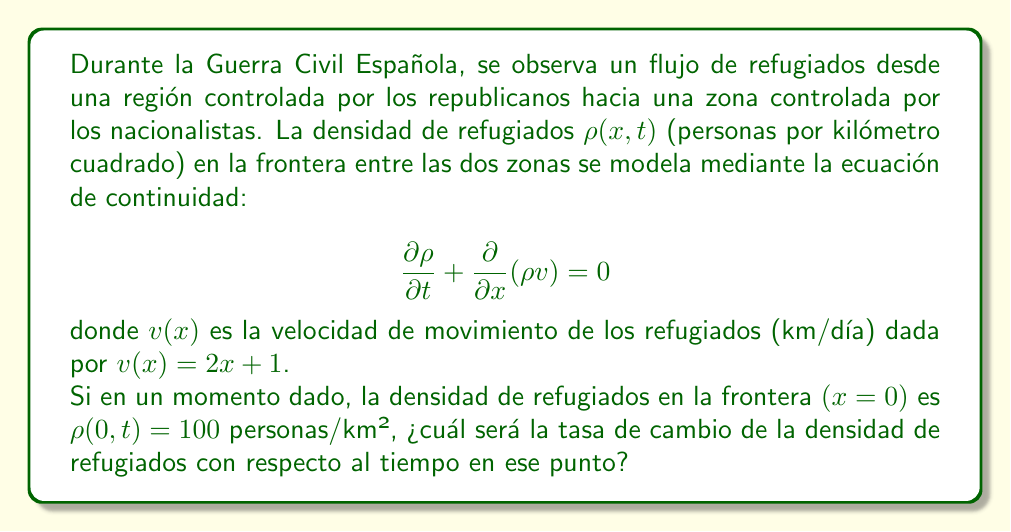Give your solution to this math problem. Para resolver este problema, seguiremos estos pasos:

1) La ecuación de continuidad dada es:

   $$\frac{\partial \rho}{\partial t} + \frac{\partial}{\partial x}(\rho v) = 0$$

2) Expandimos el segundo término usando la regla del producto:

   $$\frac{\partial \rho}{\partial t} + v\frac{\partial \rho}{\partial x} + \rho\frac{\partial v}{\partial x} = 0$$

3) Nos dan que $v(x) = 2x + 1$, por lo que $\frac{\partial v}{\partial x} = 2$

4) Sustituyendo esto en la ecuación:

   $$\frac{\partial \rho}{\partial t} + (2x + 1)\frac{\partial \rho}{\partial x} + 2\rho = 0$$

5) Nos piden evaluar en $x = 0$, donde $\rho = 100$. Sustituyendo estos valores:

   $$\frac{\partial \rho}{\partial t} + 1\frac{\partial \rho}{\partial x} + 2(100) = 0$$

6) Despejando $\frac{\partial \rho}{\partial t}$:

   $$\frac{\partial \rho}{\partial t} = -\frac{\partial \rho}{\partial x} - 200$$

Esta ecuación nos da la tasa de cambio de la densidad de refugiados con respecto al tiempo en términos de la tasa de cambio espacial de la densidad y un término constante.

7) Aunque no conocemos el valor exacto de $\frac{\partial \rho}{\partial x}$ en $x = 0$, podemos concluir que la tasa de cambio temporal de la densidad de refugiados en la frontera será 200 personas/km²/día menos que la tasa de cambio espacial negativa.
Answer: $\frac{\partial \rho}{\partial t} = -\frac{\partial \rho}{\partial x} - 200$ personas/km²/día 